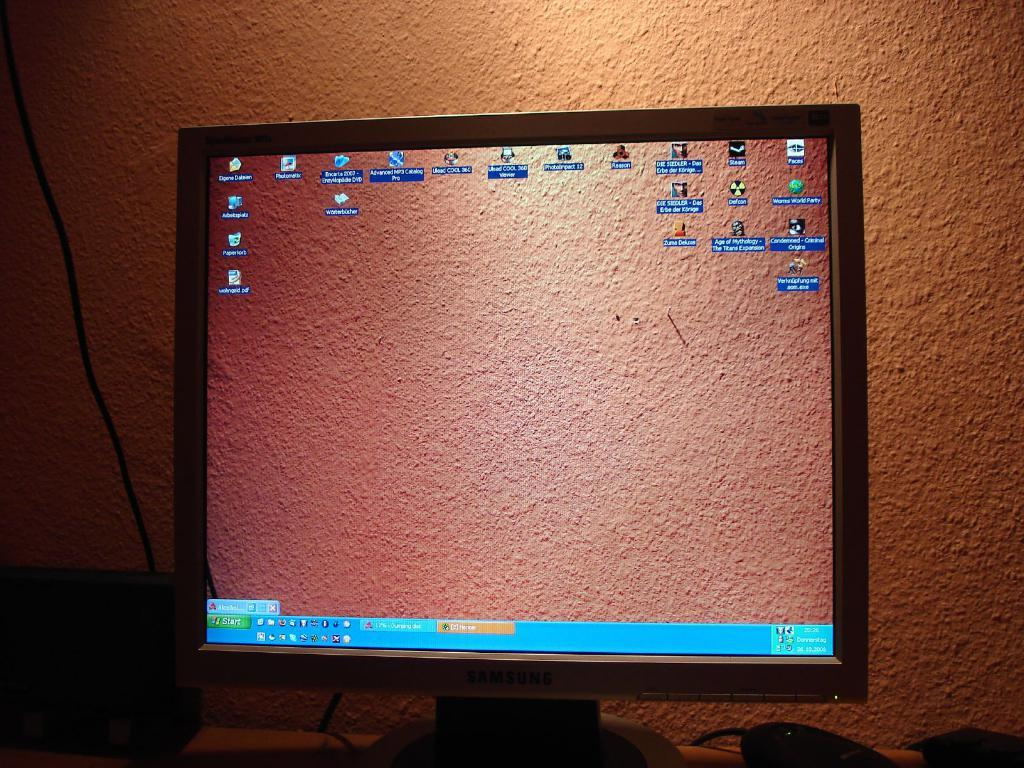<image>
Describe the image concisely. a screen shot of a computer monitor with Start Icons and windows Icons 